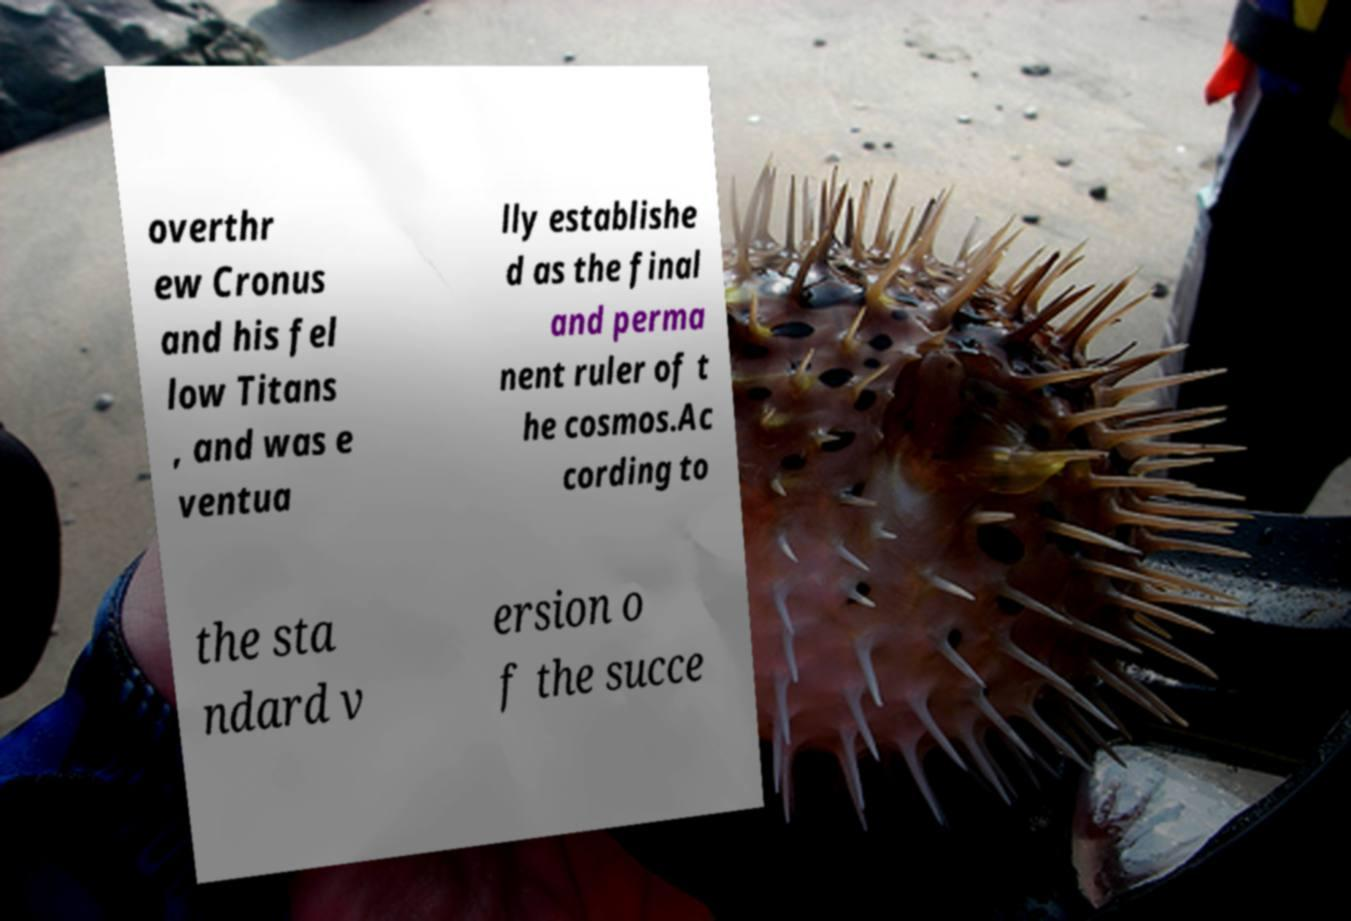Could you assist in decoding the text presented in this image and type it out clearly? overthr ew Cronus and his fel low Titans , and was e ventua lly establishe d as the final and perma nent ruler of t he cosmos.Ac cording to the sta ndard v ersion o f the succe 